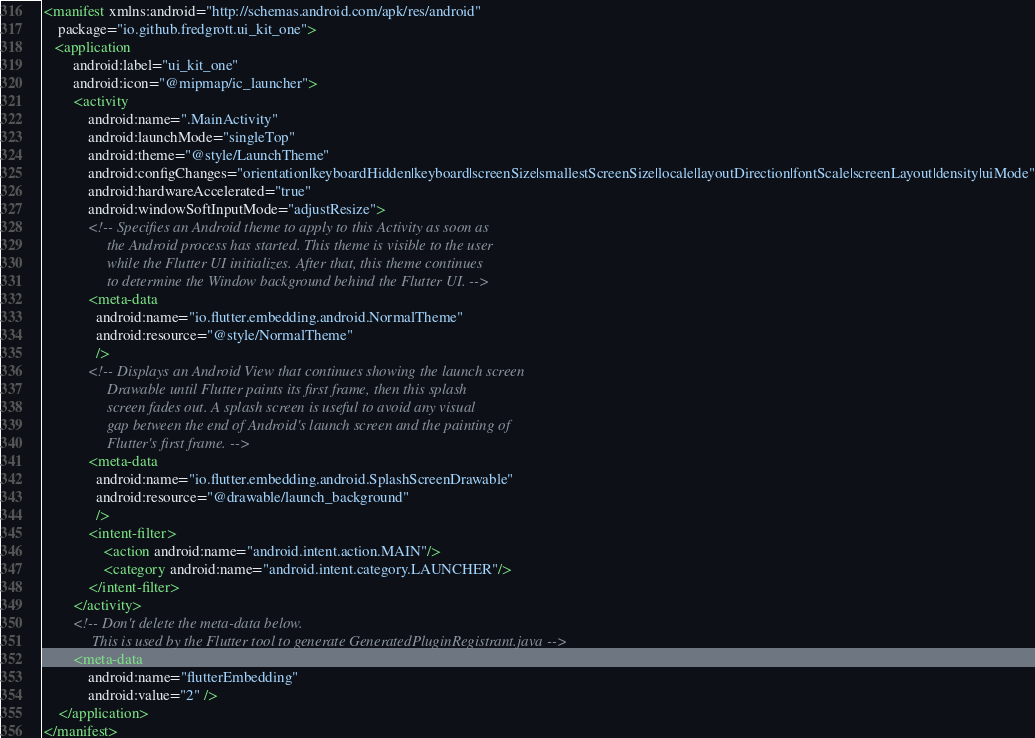Convert code to text. <code><loc_0><loc_0><loc_500><loc_500><_XML_><manifest xmlns:android="http://schemas.android.com/apk/res/android"
    package="io.github.fredgrott.ui_kit_one">
   <application
        android:label="ui_kit_one"
        android:icon="@mipmap/ic_launcher">
        <activity
            android:name=".MainActivity"
            android:launchMode="singleTop"
            android:theme="@style/LaunchTheme"
            android:configChanges="orientation|keyboardHidden|keyboard|screenSize|smallestScreenSize|locale|layoutDirection|fontScale|screenLayout|density|uiMode"
            android:hardwareAccelerated="true"
            android:windowSoftInputMode="adjustResize">
            <!-- Specifies an Android theme to apply to this Activity as soon as
                 the Android process has started. This theme is visible to the user
                 while the Flutter UI initializes. After that, this theme continues
                 to determine the Window background behind the Flutter UI. -->
            <meta-data
              android:name="io.flutter.embedding.android.NormalTheme"
              android:resource="@style/NormalTheme"
              />
            <!-- Displays an Android View that continues showing the launch screen
                 Drawable until Flutter paints its first frame, then this splash
                 screen fades out. A splash screen is useful to avoid any visual
                 gap between the end of Android's launch screen and the painting of
                 Flutter's first frame. -->
            <meta-data
              android:name="io.flutter.embedding.android.SplashScreenDrawable"
              android:resource="@drawable/launch_background"
              />
            <intent-filter>
                <action android:name="android.intent.action.MAIN"/>
                <category android:name="android.intent.category.LAUNCHER"/>
            </intent-filter>
        </activity>
        <!-- Don't delete the meta-data below.
             This is used by the Flutter tool to generate GeneratedPluginRegistrant.java -->
        <meta-data
            android:name="flutterEmbedding"
            android:value="2" />
    </application>
</manifest>
</code> 